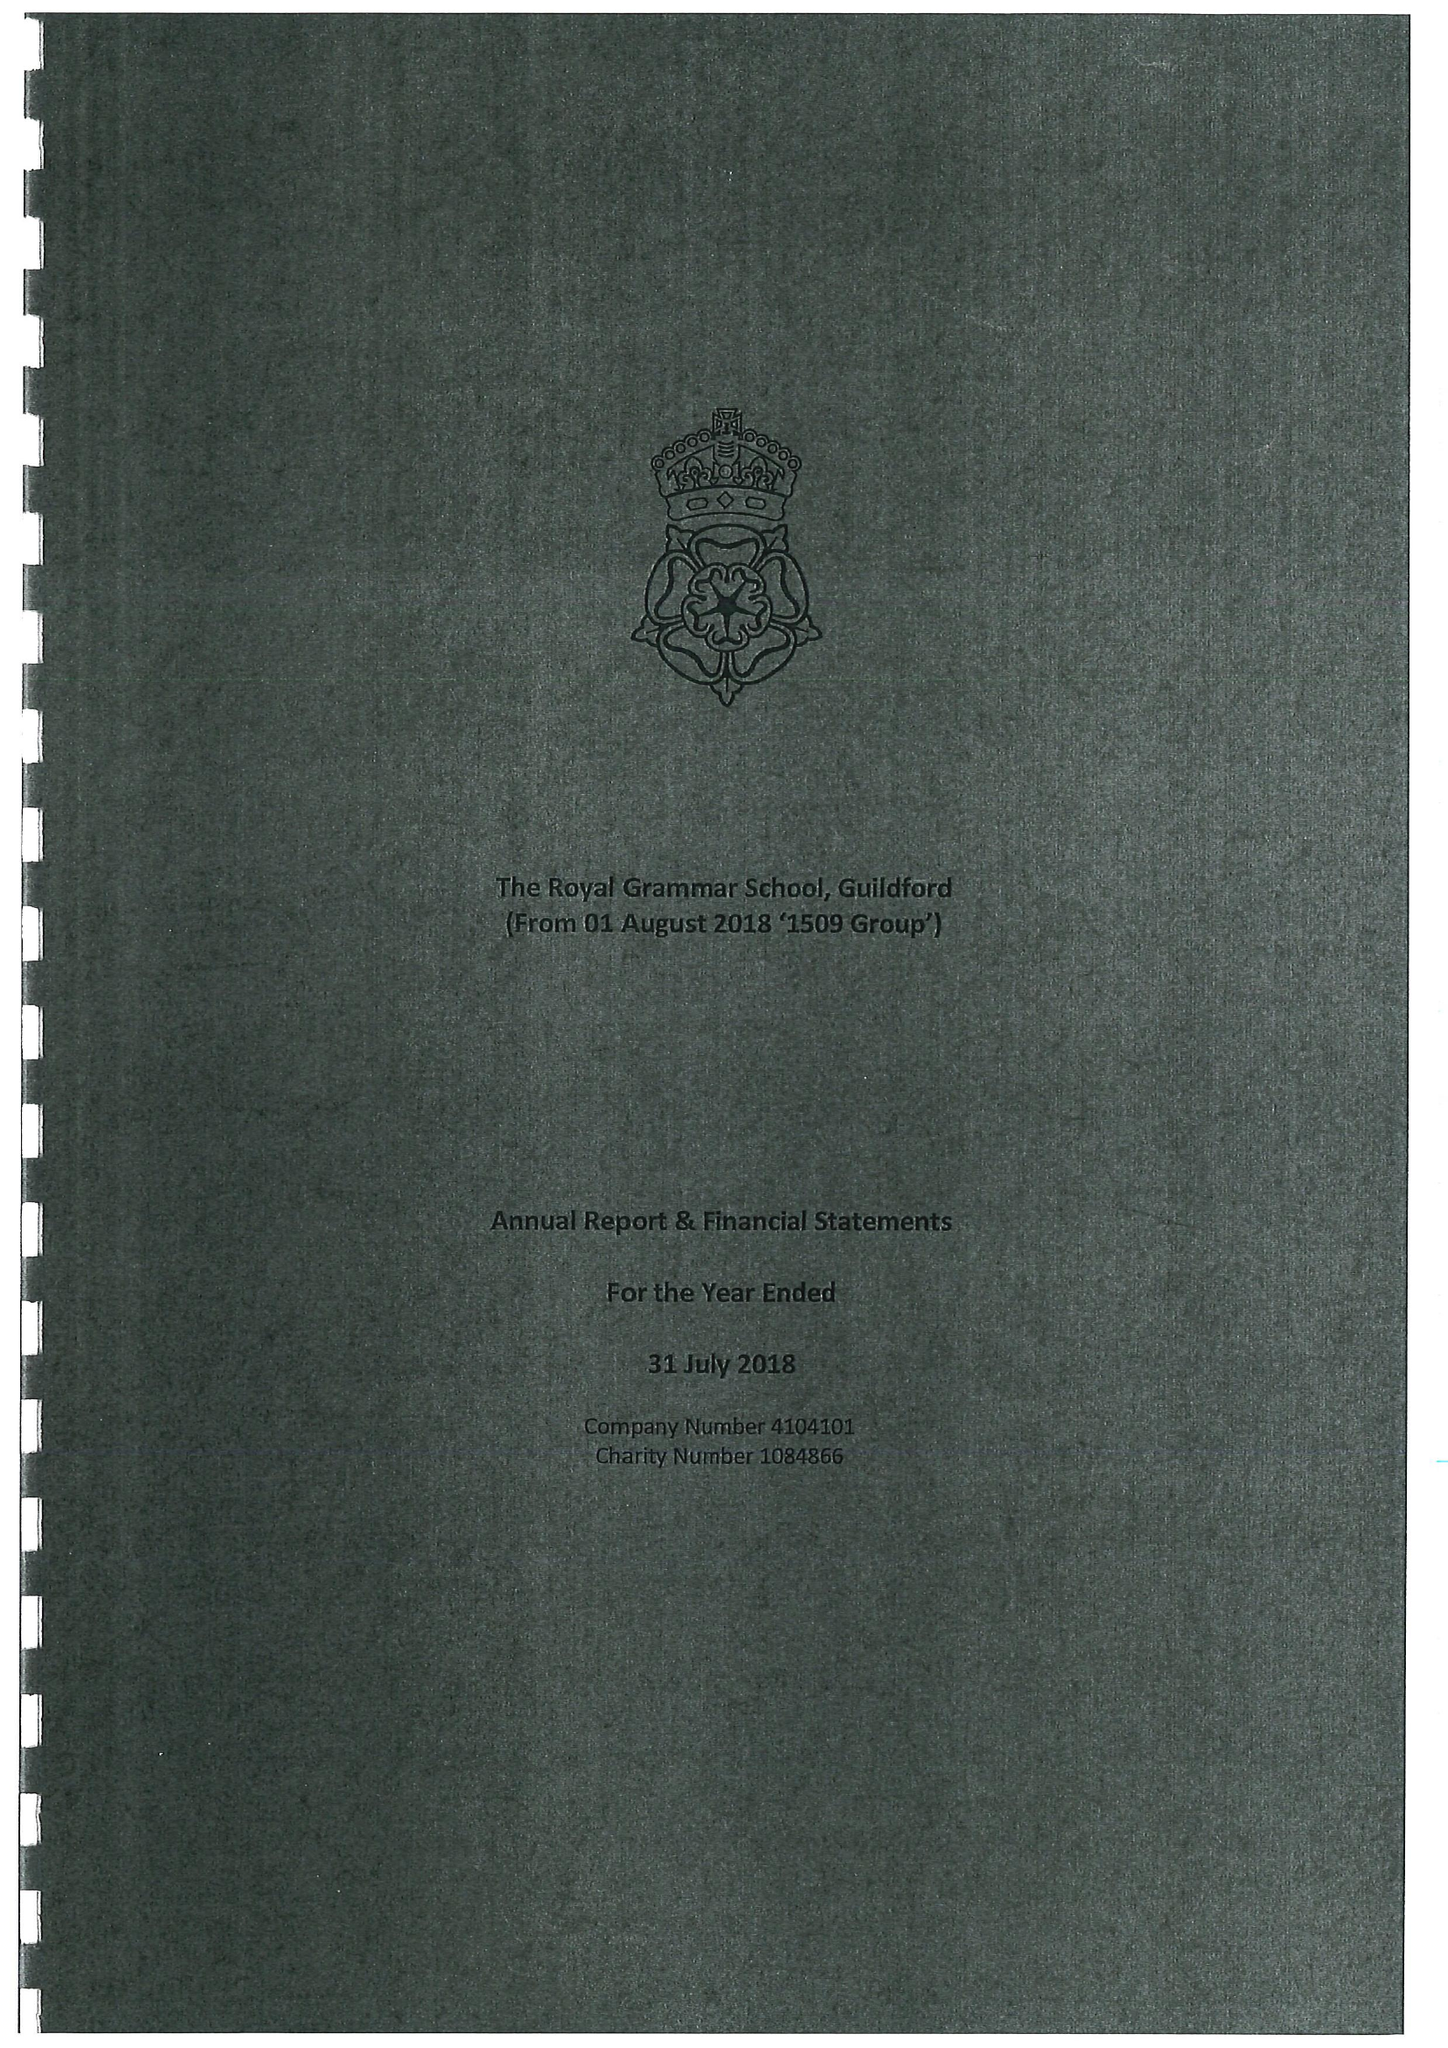What is the value for the address__post_town?
Answer the question using a single word or phrase. GUILDFORD 